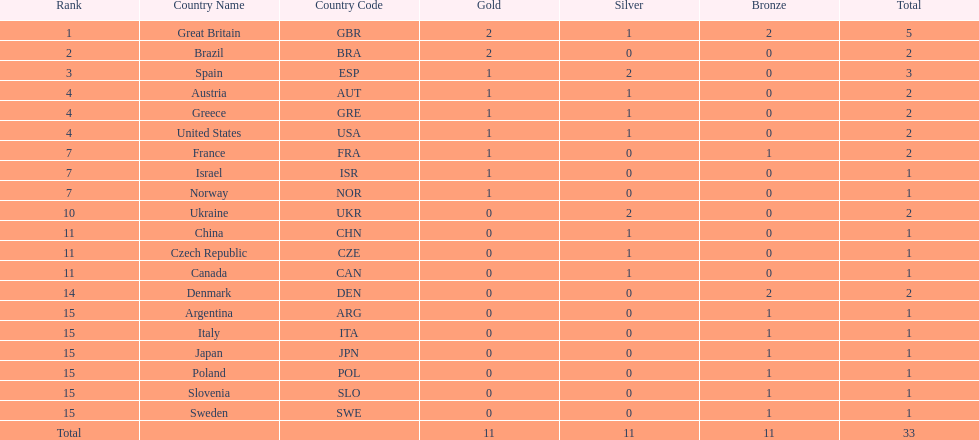Which nation received 2 silver medals? Spain (ESP), Ukraine (UKR). Of those, which nation also had 2 total medals? Spain (ESP). 